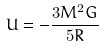Convert formula to latex. <formula><loc_0><loc_0><loc_500><loc_500>U = - \frac { 3 M ^ { 2 } G } { 5 R }</formula> 